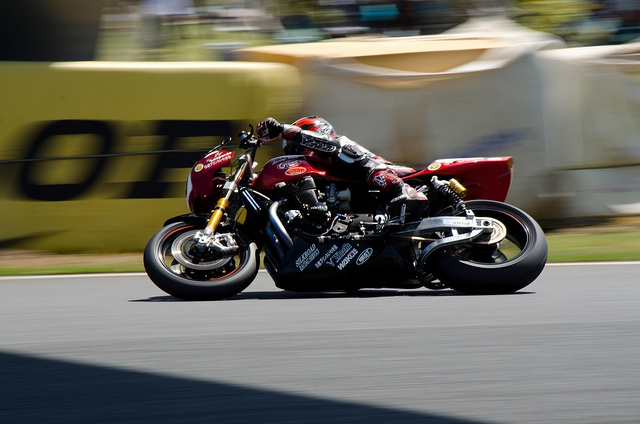Describe the objects in this image and their specific colors. I can see motorcycle in black, gray, white, and darkgray tones and people in black, lightgray, gray, and darkgray tones in this image. 